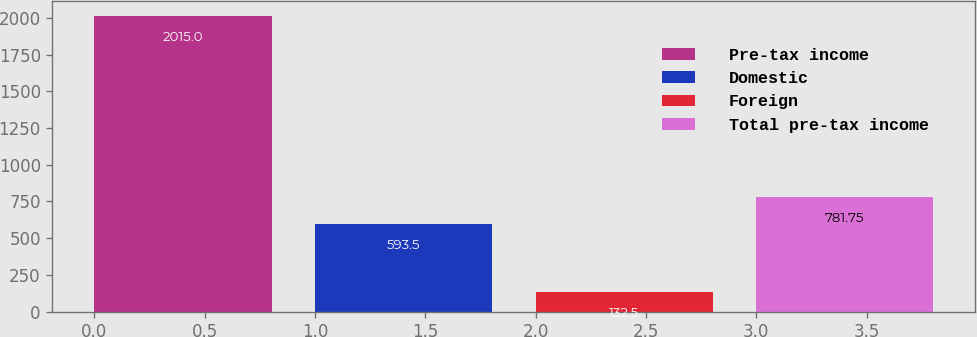Convert chart to OTSL. <chart><loc_0><loc_0><loc_500><loc_500><bar_chart><fcel>Pre-tax income<fcel>Domestic<fcel>Foreign<fcel>Total pre-tax income<nl><fcel>2015<fcel>593.5<fcel>132.5<fcel>781.75<nl></chart> 